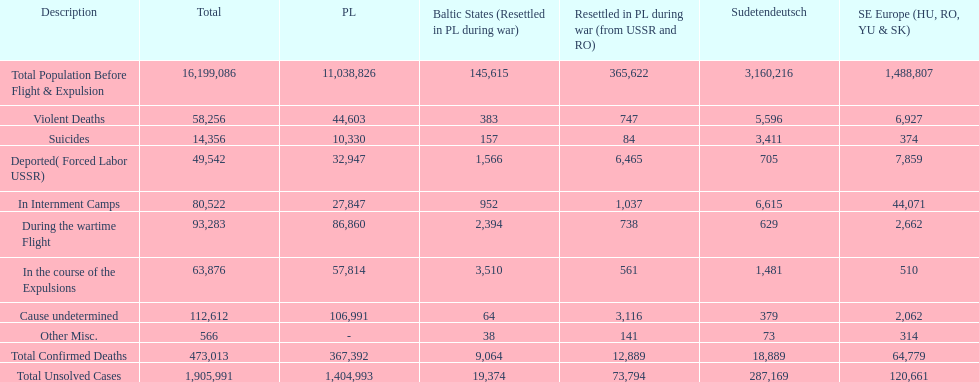What is the total of deaths in internment camps and during the wartime flight? 173,805. 